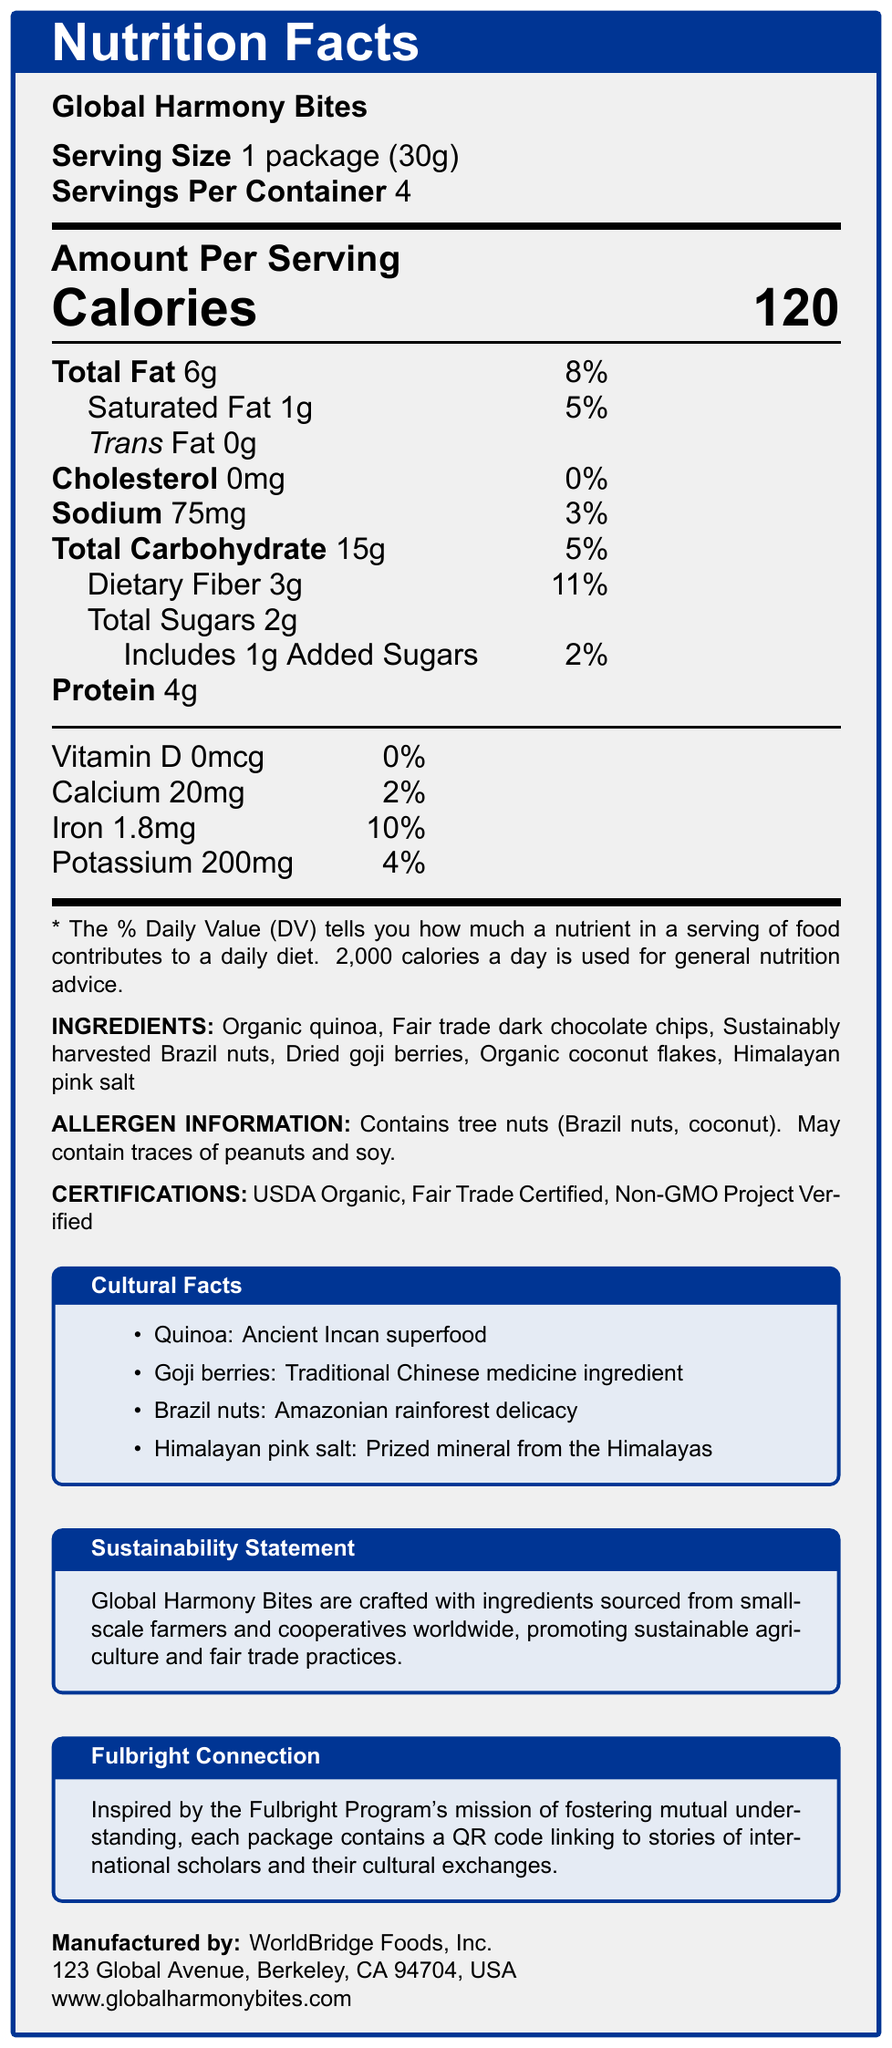what is the serving size for Global Harmony Bites? The serving size is explicitly stated as "1 package (30g)".
Answer: 1 package (30g) how many servings are there per container of Global Harmony Bites? The document states "Servings Per Container: 4".
Answer: 4 how many calories are there per serving of Global Harmony Bites? The document mentions "Calories: 120" under the "Amount Per Serving" section.
Answer: 120 calories how much total fat does one serving of Global Harmony Bites contain? The "Total Fat" amount is listed as "6g".
Answer: 6g what percentage of the daily value does the dietary fiber in one serving of Global Harmony Bites contribute? Under "Dietary Fiber", the daily value percentage is given as "11%".
Answer: 11% which ingredient is not mentioned in the ingredients list? A. Organic quinoa B. Fair trade dark chocolate chips C. Organic apple slices D. Dried goji berries The ingredients listed do not include "Organic apple slices".
Answer: C. Organic apple slices what is the daily value percentage of iron in one serving of Global Harmony Bites? The "Iron" amount shows "1.8mg" with a daily value percentage of "10%".
Answer: 10% how much calcium is in one serving of Global Harmony Bites? "Calcium" is listed with an amount of "20mg".
Answer: 20mg what certifications does Global Harmony Bites have? A. USDA Organic B. Fair Trade Certified C. Non-GMO Project Verified D. All of the above The document lists all three certifications under "CERTIFICATIONS".
Answer: D. All of the above are there any traces of peanuts and soy in Global Harmony Bites? The "ALLERGEN INFORMATION" section states that the product "May contain traces of peanuts and soy".
Answer: Yes summarize the main idea of the document. The document primarily focuses on presenting the nutritional facts about Global Harmony Bites, highlighting its certifications, ingredients, allergen information, and the cultural and sustainability aspects that connect to the Fulbright Program's goals.
Answer: The document provides detailed nutritional information and ingredient list for Global Harmony Bites, a sustainably sourced snack. It includes serving size, calories, and the daily values of various nutrients such as fats, cholesterol, sodium, carbohydrates, and vitamins. The snack is certified organic, fair trade, and non-GMO, created with ingredients promoting cultural understanding and sustainability. The allergens are listed, and it emphasizes the connection to the Fulbright Program's mission of fostering mutual understanding. who manufactures Global Harmony Bites? The manufacturer's information is provided at the end of the document as "WorldBridge Foods, Inc."
Answer: WorldBridge Foods, Inc. how much sodium does one serving of Global Harmony Bites contain? The "Sodium" content is listed as "75mg".
Answer: 75mg how many grams of added sugars are in one serving? The "Includes 1g Added Sugars" is listed under the "Total Sugars" section.
Answer: 1g where is WorldBridge Foods, Inc. located? The address is clearly stated at the end of the document.
Answer: 123 Global Avenue, Berkeley, CA 94704, USA what specific Fulbright connection is mentioned in the document? The "Fulbright Connection" section provides this information.
Answer: Each package contains a QR code linking to stories of international scholars and their cultural exchanges. which ingredient in Global Harmony Bites is a traditional Chinese medicine ingredient? Under "Cultural Facts", goji berries are described as a "Traditional Chinese medicine ingredient".
Answer: Goji berries what is the total carbohydrate content per serving, and what percentage of the daily value does it represent? The document lists "Total Carbohydrate: 15g" and "5%" for the daily value.
Answer: 15g, 5% how many grams of protein are there per serving of Global Harmony Bites? The protein content is listed as "4g".
Answer: 4g what is the price of Global Harmony Bites? The document does not provide any information regarding the price of the product.
Answer: Cannot be determined 